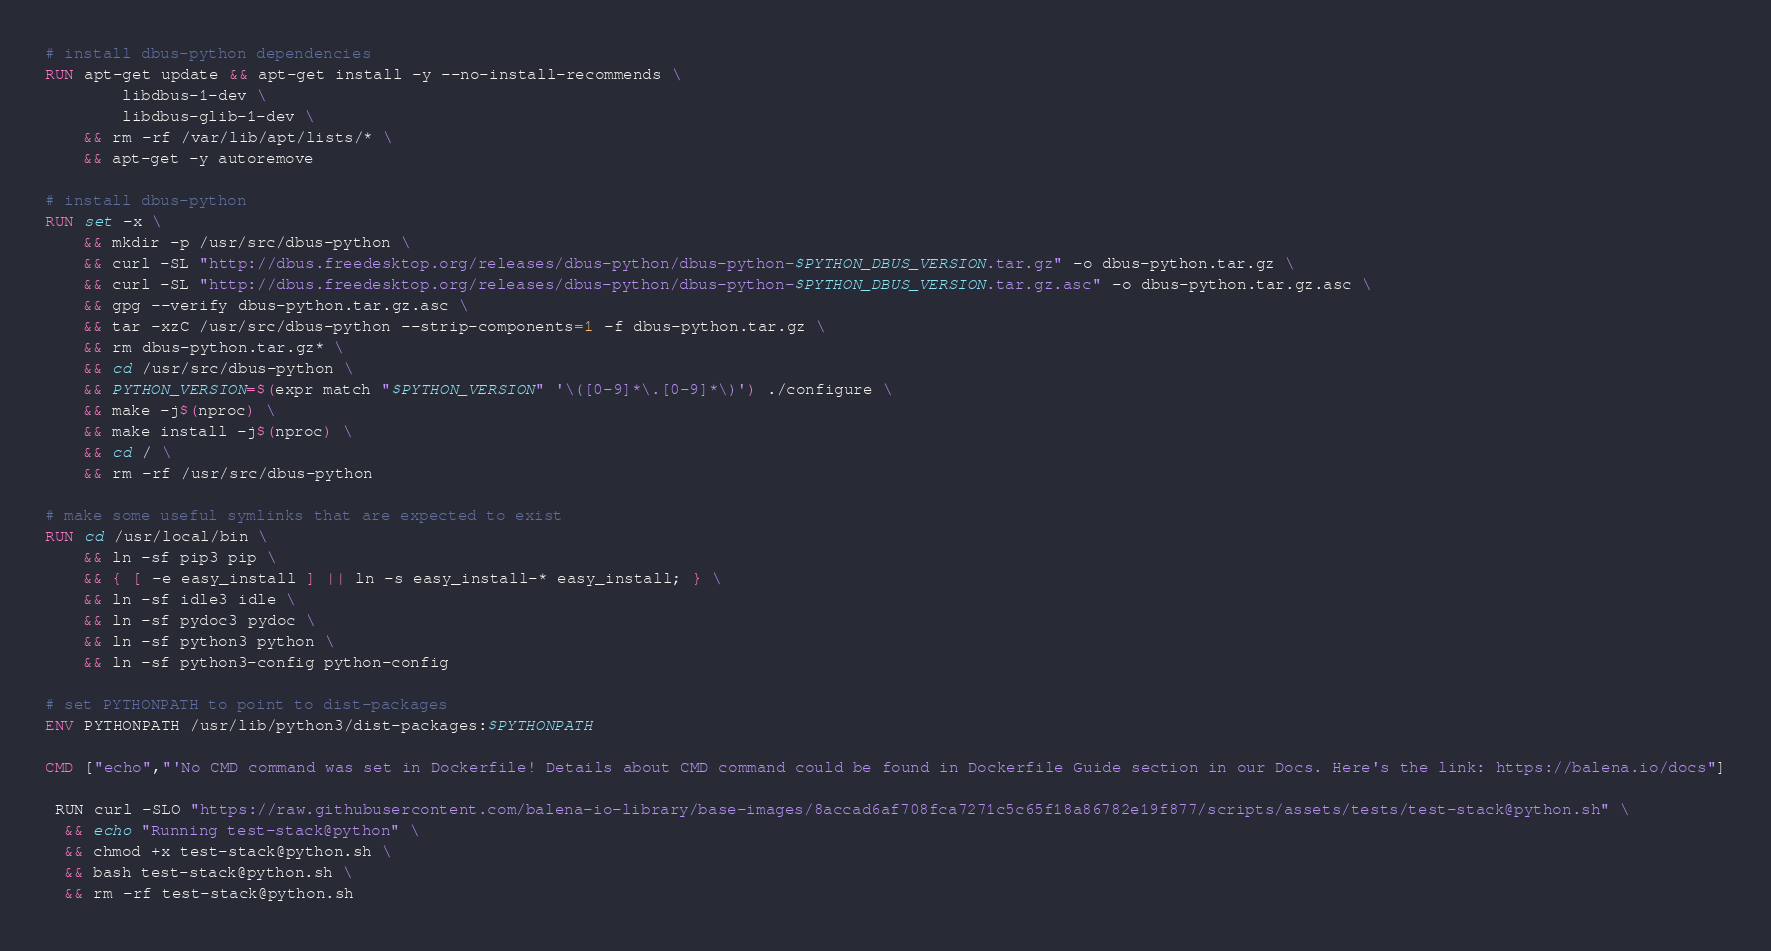<code> <loc_0><loc_0><loc_500><loc_500><_Dockerfile_># install dbus-python dependencies 
RUN apt-get update && apt-get install -y --no-install-recommends \
		libdbus-1-dev \
		libdbus-glib-1-dev \
	&& rm -rf /var/lib/apt/lists/* \
	&& apt-get -y autoremove

# install dbus-python
RUN set -x \
	&& mkdir -p /usr/src/dbus-python \
	&& curl -SL "http://dbus.freedesktop.org/releases/dbus-python/dbus-python-$PYTHON_DBUS_VERSION.tar.gz" -o dbus-python.tar.gz \
	&& curl -SL "http://dbus.freedesktop.org/releases/dbus-python/dbus-python-$PYTHON_DBUS_VERSION.tar.gz.asc" -o dbus-python.tar.gz.asc \
	&& gpg --verify dbus-python.tar.gz.asc \
	&& tar -xzC /usr/src/dbus-python --strip-components=1 -f dbus-python.tar.gz \
	&& rm dbus-python.tar.gz* \
	&& cd /usr/src/dbus-python \
	&& PYTHON_VERSION=$(expr match "$PYTHON_VERSION" '\([0-9]*\.[0-9]*\)') ./configure \
	&& make -j$(nproc) \
	&& make install -j$(nproc) \
	&& cd / \
	&& rm -rf /usr/src/dbus-python

# make some useful symlinks that are expected to exist
RUN cd /usr/local/bin \
	&& ln -sf pip3 pip \
	&& { [ -e easy_install ] || ln -s easy_install-* easy_install; } \
	&& ln -sf idle3 idle \
	&& ln -sf pydoc3 pydoc \
	&& ln -sf python3 python \
	&& ln -sf python3-config python-config

# set PYTHONPATH to point to dist-packages
ENV PYTHONPATH /usr/lib/python3/dist-packages:$PYTHONPATH

CMD ["echo","'No CMD command was set in Dockerfile! Details about CMD command could be found in Dockerfile Guide section in our Docs. Here's the link: https://balena.io/docs"]

 RUN curl -SLO "https://raw.githubusercontent.com/balena-io-library/base-images/8accad6af708fca7271c5c65f18a86782e19f877/scripts/assets/tests/test-stack@python.sh" \
  && echo "Running test-stack@python" \
  && chmod +x test-stack@python.sh \
  && bash test-stack@python.sh \
  && rm -rf test-stack@python.sh 
</code> 